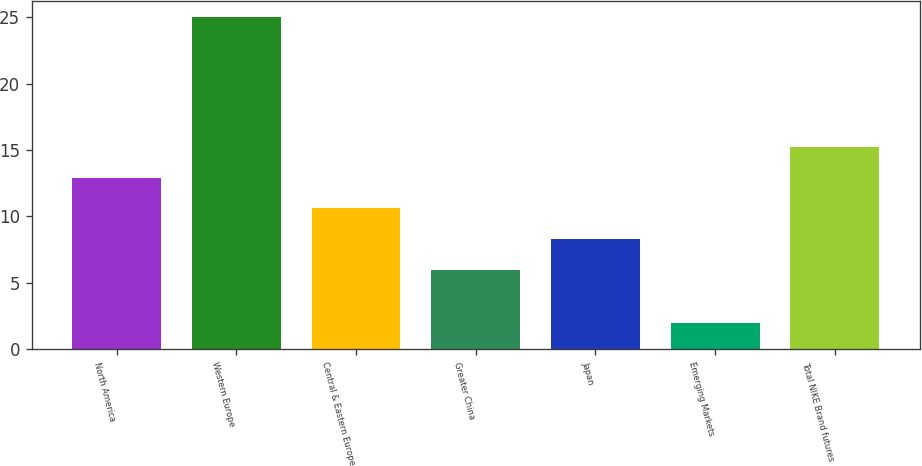Convert chart. <chart><loc_0><loc_0><loc_500><loc_500><bar_chart><fcel>North America<fcel>Western Europe<fcel>Central & Eastern Europe<fcel>Greater China<fcel>Japan<fcel>Emerging Markets<fcel>Total NIKE Brand futures<nl><fcel>12.9<fcel>25<fcel>10.6<fcel>6<fcel>8.3<fcel>2<fcel>15.2<nl></chart> 